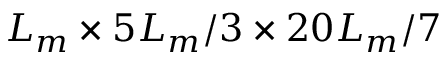<formula> <loc_0><loc_0><loc_500><loc_500>L _ { m } \times 5 L _ { m } / 3 \times 2 0 L _ { m } / 7</formula> 